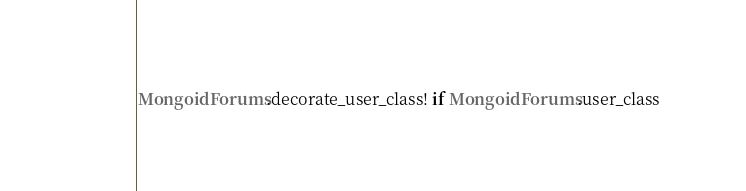Convert code to text. <code><loc_0><loc_0><loc_500><loc_500><_Ruby_>MongoidForums.decorate_user_class! if MongoidForums.user_class
</code> 